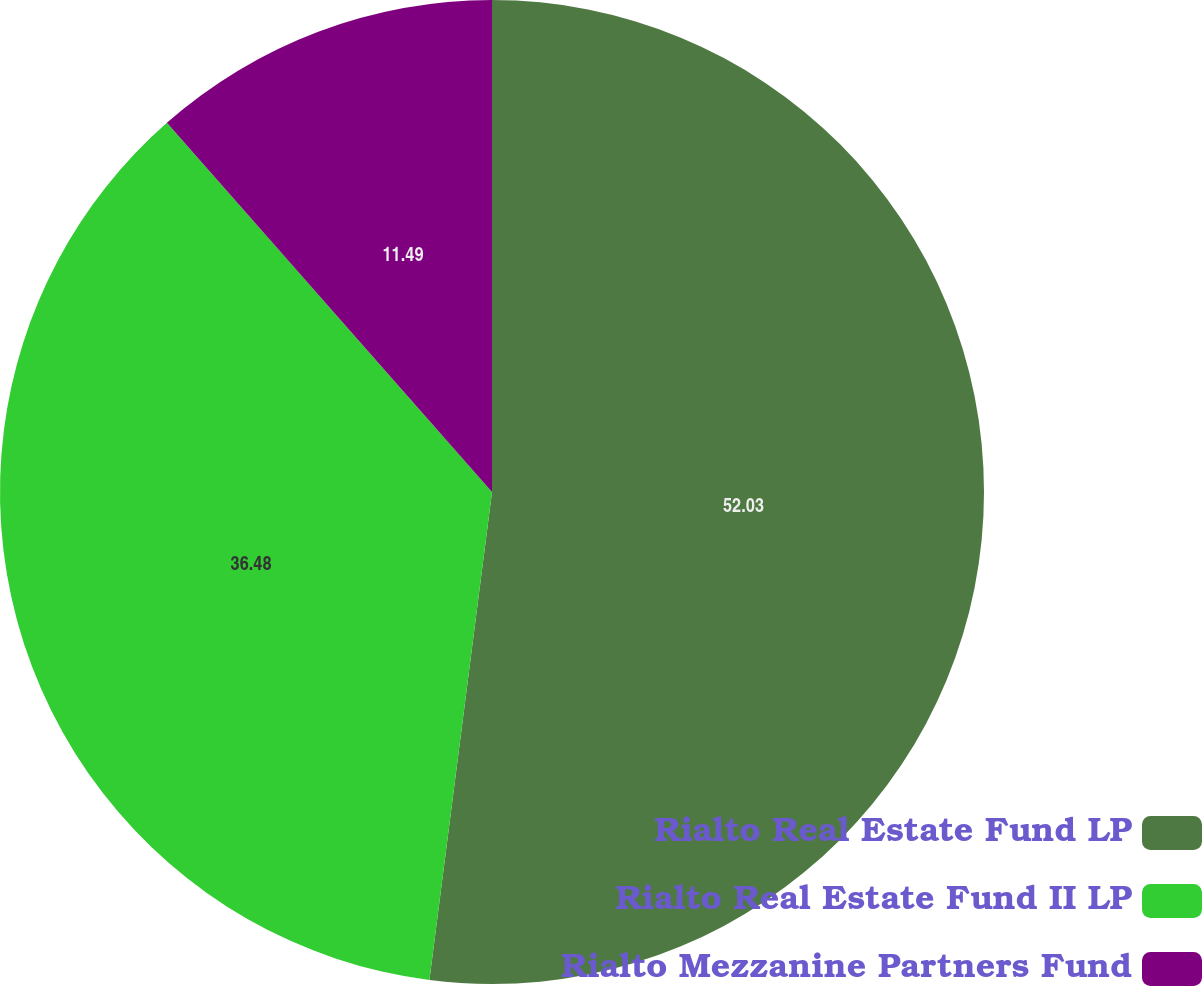Convert chart. <chart><loc_0><loc_0><loc_500><loc_500><pie_chart><fcel>Rialto Real Estate Fund LP<fcel>Rialto Real Estate Fund II LP<fcel>Rialto Mezzanine Partners Fund<nl><fcel>52.03%<fcel>36.48%<fcel>11.49%<nl></chart> 